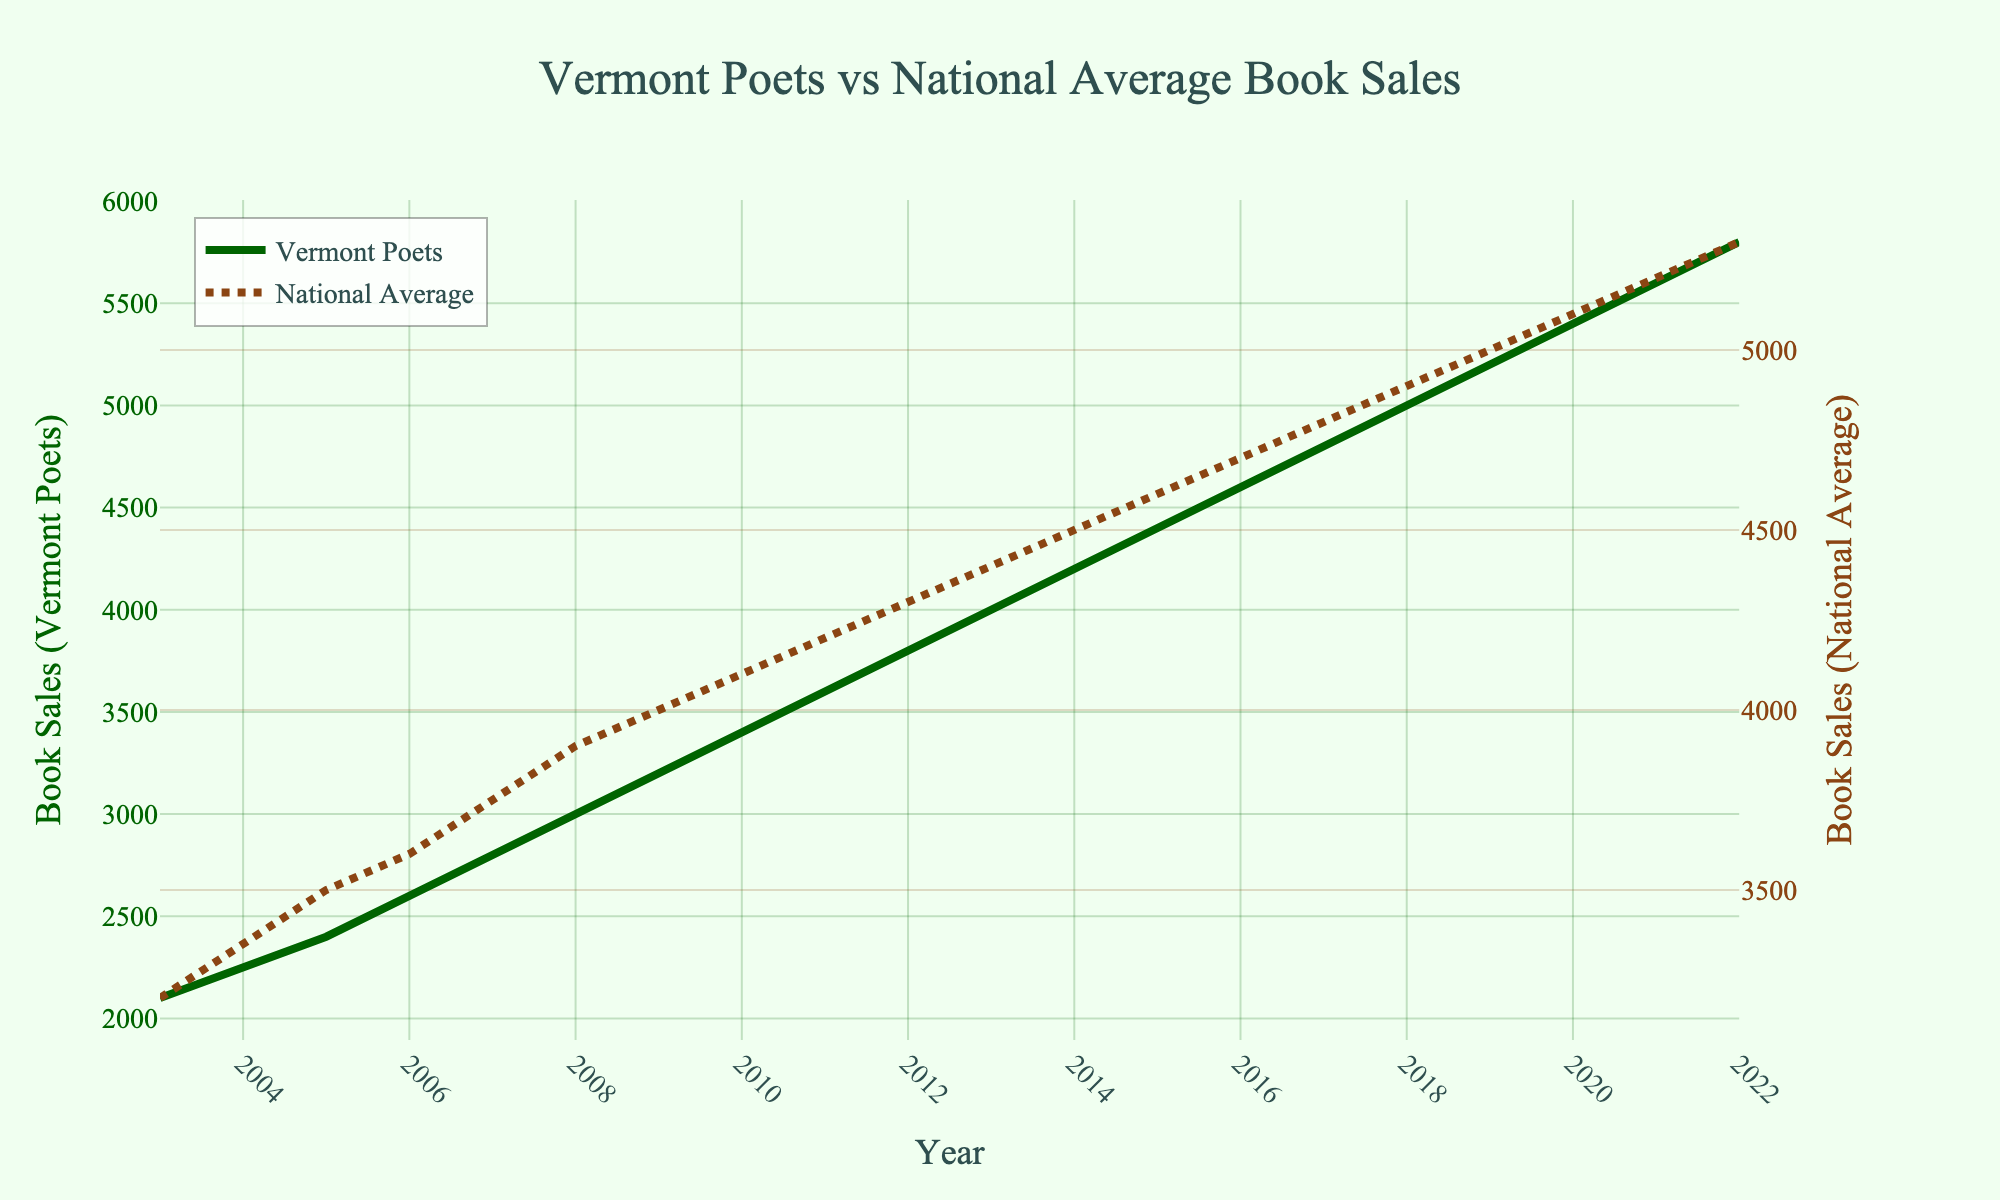Which year shows the highest book sales for Vermont poets? To determine the year with the highest book sales for Vermont poets, look at the green line representing Vermont Poets on the chart and identify the peak point. The peak occurs at the far right end of the graph, which corresponds to the year 2022.
Answer: 2022 How do book sales for Vermont poets in 2017 compare to the national average in the same year? Find the data points for the year 2017 on both the green Vermont Poets line and the brown National Average line. Both are at 4800, indicating that the book sales are equal.
Answer: Equal What is the average book sales for Vermont poets from 2003 to 2022? Calculate the sum of the Vermont Poets sales figures from 2003 to 2022, then divide by the number of years (20). Sum = 2100+2250+2400+2600+2800+3000+3200+3400+3600+3800+4000+4200+4400+4600+4800+5000+5200+5400+5600+5800 = 86,450. Average = 86,450/20 = 4322.5.
Answer: 4322.5 Between 2008 and 2010, which year experienced the highest increase in book sales for Vermont poets? Identify the book sales values for Vermont poets in the years 2008, 2009, and 2010: 2008 (3000), 2009 (3200), 2010 (3400). Calculate the increases: 2009-2008 = 3200-3000 = 200, and 2010-2009 = 3400-3200 = 200. The increase is the same in both years.
Answer: 2009, 2010 Identify the color and style of the line that represents the national average book sales. Examine the visual attributes of the line representing the National Average. It is a brown, dashed line with circular markers.
Answer: Brown, dashed What was the difference in book sales between Vermont Poets and the national average in 2006? Locate the 2006 data points for both Vermont Poets and the National Average: Vermont Poets (2600) and National Average (3600). Calculate the difference: 3600 - 2600 = 1000.
Answer: 1000 Which year shows the smallest difference between book sales for Vermont poets and the national average? Compare the distance between the two lines for each year. The lines intersect in 2017, showing the smallest difference, which is zero.
Answer: 2017 What is the overall trend in book sales for Vermont poets from 2003 to 2022? Observe the direction of the Vermont Poets line from 2003 to 2022. The line consistently rises, indicating a steady increase in book sales over the years.
Answer: Increasing In which year did Vermont poets' book sales first surpass 5000? Identify the first year where the Vermont Poets' line crosses the 5000 mark. This occurs in 2018.
Answer: 2018 